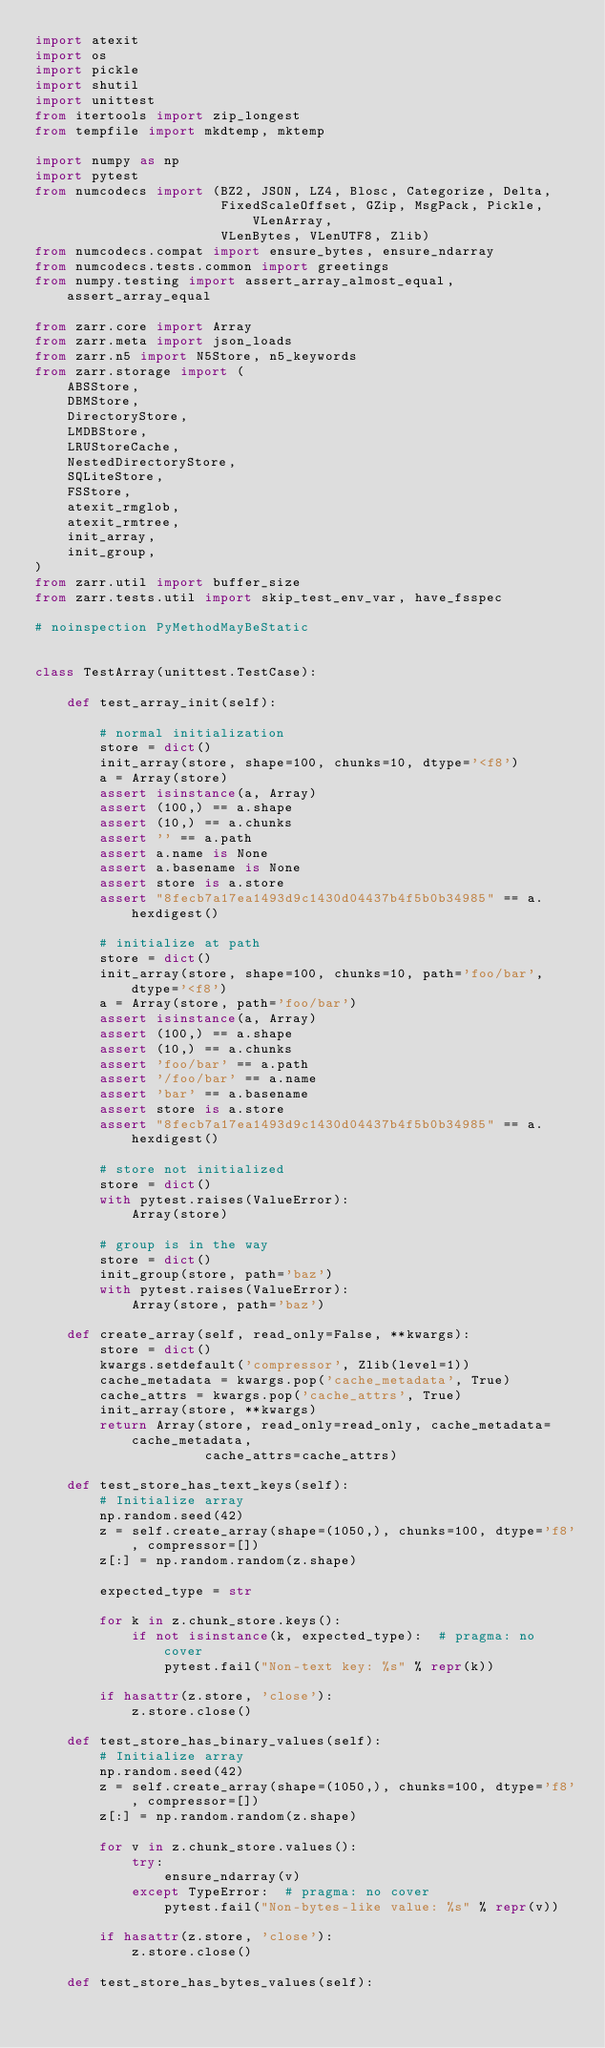<code> <loc_0><loc_0><loc_500><loc_500><_Python_>import atexit
import os
import pickle
import shutil
import unittest
from itertools import zip_longest
from tempfile import mkdtemp, mktemp

import numpy as np
import pytest
from numcodecs import (BZ2, JSON, LZ4, Blosc, Categorize, Delta,
                       FixedScaleOffset, GZip, MsgPack, Pickle, VLenArray,
                       VLenBytes, VLenUTF8, Zlib)
from numcodecs.compat import ensure_bytes, ensure_ndarray
from numcodecs.tests.common import greetings
from numpy.testing import assert_array_almost_equal, assert_array_equal

from zarr.core import Array
from zarr.meta import json_loads
from zarr.n5 import N5Store, n5_keywords
from zarr.storage import (
    ABSStore,
    DBMStore,
    DirectoryStore,
    LMDBStore,
    LRUStoreCache,
    NestedDirectoryStore,
    SQLiteStore,
    FSStore,
    atexit_rmglob,
    atexit_rmtree,
    init_array,
    init_group,
)
from zarr.util import buffer_size
from zarr.tests.util import skip_test_env_var, have_fsspec

# noinspection PyMethodMayBeStatic


class TestArray(unittest.TestCase):

    def test_array_init(self):

        # normal initialization
        store = dict()
        init_array(store, shape=100, chunks=10, dtype='<f8')
        a = Array(store)
        assert isinstance(a, Array)
        assert (100,) == a.shape
        assert (10,) == a.chunks
        assert '' == a.path
        assert a.name is None
        assert a.basename is None
        assert store is a.store
        assert "8fecb7a17ea1493d9c1430d04437b4f5b0b34985" == a.hexdigest()

        # initialize at path
        store = dict()
        init_array(store, shape=100, chunks=10, path='foo/bar', dtype='<f8')
        a = Array(store, path='foo/bar')
        assert isinstance(a, Array)
        assert (100,) == a.shape
        assert (10,) == a.chunks
        assert 'foo/bar' == a.path
        assert '/foo/bar' == a.name
        assert 'bar' == a.basename
        assert store is a.store
        assert "8fecb7a17ea1493d9c1430d04437b4f5b0b34985" == a.hexdigest()

        # store not initialized
        store = dict()
        with pytest.raises(ValueError):
            Array(store)

        # group is in the way
        store = dict()
        init_group(store, path='baz')
        with pytest.raises(ValueError):
            Array(store, path='baz')

    def create_array(self, read_only=False, **kwargs):
        store = dict()
        kwargs.setdefault('compressor', Zlib(level=1))
        cache_metadata = kwargs.pop('cache_metadata', True)
        cache_attrs = kwargs.pop('cache_attrs', True)
        init_array(store, **kwargs)
        return Array(store, read_only=read_only, cache_metadata=cache_metadata,
                     cache_attrs=cache_attrs)

    def test_store_has_text_keys(self):
        # Initialize array
        np.random.seed(42)
        z = self.create_array(shape=(1050,), chunks=100, dtype='f8', compressor=[])
        z[:] = np.random.random(z.shape)

        expected_type = str

        for k in z.chunk_store.keys():
            if not isinstance(k, expected_type):  # pragma: no cover
                pytest.fail("Non-text key: %s" % repr(k))

        if hasattr(z.store, 'close'):
            z.store.close()

    def test_store_has_binary_values(self):
        # Initialize array
        np.random.seed(42)
        z = self.create_array(shape=(1050,), chunks=100, dtype='f8', compressor=[])
        z[:] = np.random.random(z.shape)

        for v in z.chunk_store.values():
            try:
                ensure_ndarray(v)
            except TypeError:  # pragma: no cover
                pytest.fail("Non-bytes-like value: %s" % repr(v))

        if hasattr(z.store, 'close'):
            z.store.close()

    def test_store_has_bytes_values(self):</code> 